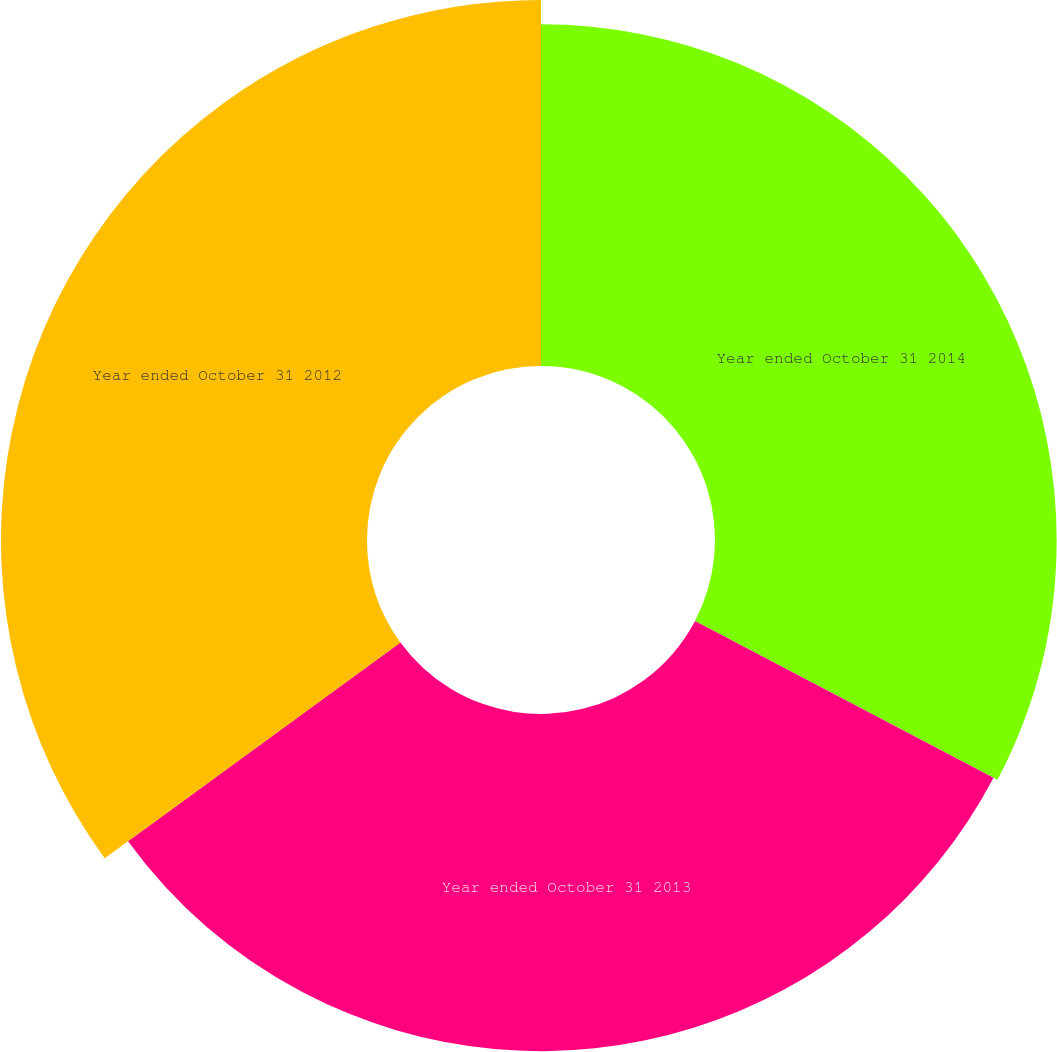<chart> <loc_0><loc_0><loc_500><loc_500><pie_chart><fcel>Year ended October 31 2014<fcel>Year ended October 31 2013<fcel>Year ended October 31 2012<nl><fcel>32.7%<fcel>32.27%<fcel>35.03%<nl></chart> 